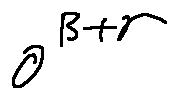Convert formula to latex. <formula><loc_0><loc_0><loc_500><loc_500>o ^ { \beta + r }</formula> 